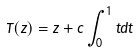<formula> <loc_0><loc_0><loc_500><loc_500>T ( z ) = z + c \int _ { 0 } ^ { 1 } t d t</formula> 